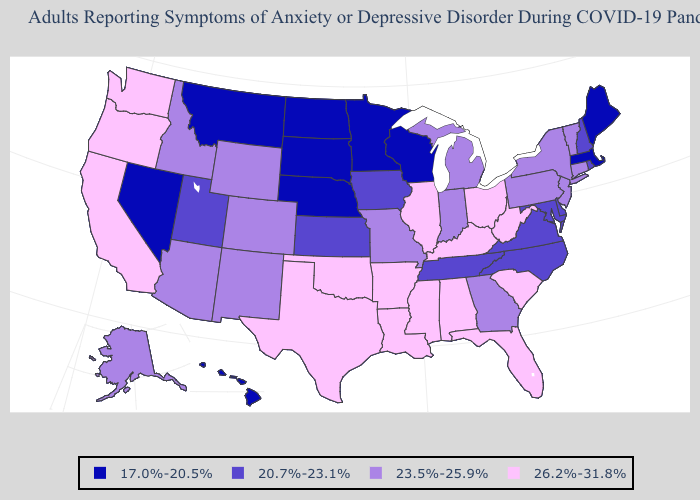Among the states that border Idaho , which have the highest value?
Keep it brief. Oregon, Washington. What is the value of Kentucky?
Short answer required. 26.2%-31.8%. Does Ohio have the highest value in the USA?
Concise answer only. Yes. Which states have the highest value in the USA?
Answer briefly. Alabama, Arkansas, California, Florida, Illinois, Kentucky, Louisiana, Mississippi, Ohio, Oklahoma, Oregon, South Carolina, Texas, Washington, West Virginia. Among the states that border Oregon , does Washington have the highest value?
Quick response, please. Yes. Does Wisconsin have the lowest value in the USA?
Quick response, please. Yes. Does California have the highest value in the USA?
Give a very brief answer. Yes. Which states have the lowest value in the USA?
Short answer required. Hawaii, Maine, Massachusetts, Minnesota, Montana, Nebraska, Nevada, North Dakota, South Dakota, Wisconsin. What is the highest value in the USA?
Answer briefly. 26.2%-31.8%. Name the states that have a value in the range 17.0%-20.5%?
Quick response, please. Hawaii, Maine, Massachusetts, Minnesota, Montana, Nebraska, Nevada, North Dakota, South Dakota, Wisconsin. What is the highest value in the USA?
Write a very short answer. 26.2%-31.8%. How many symbols are there in the legend?
Quick response, please. 4. Name the states that have a value in the range 23.5%-25.9%?
Concise answer only. Alaska, Arizona, Colorado, Connecticut, Georgia, Idaho, Indiana, Michigan, Missouri, New Jersey, New Mexico, New York, Pennsylvania, Vermont, Wyoming. Which states have the lowest value in the Northeast?
Answer briefly. Maine, Massachusetts. Which states hav the highest value in the South?
Be succinct. Alabama, Arkansas, Florida, Kentucky, Louisiana, Mississippi, Oklahoma, South Carolina, Texas, West Virginia. 